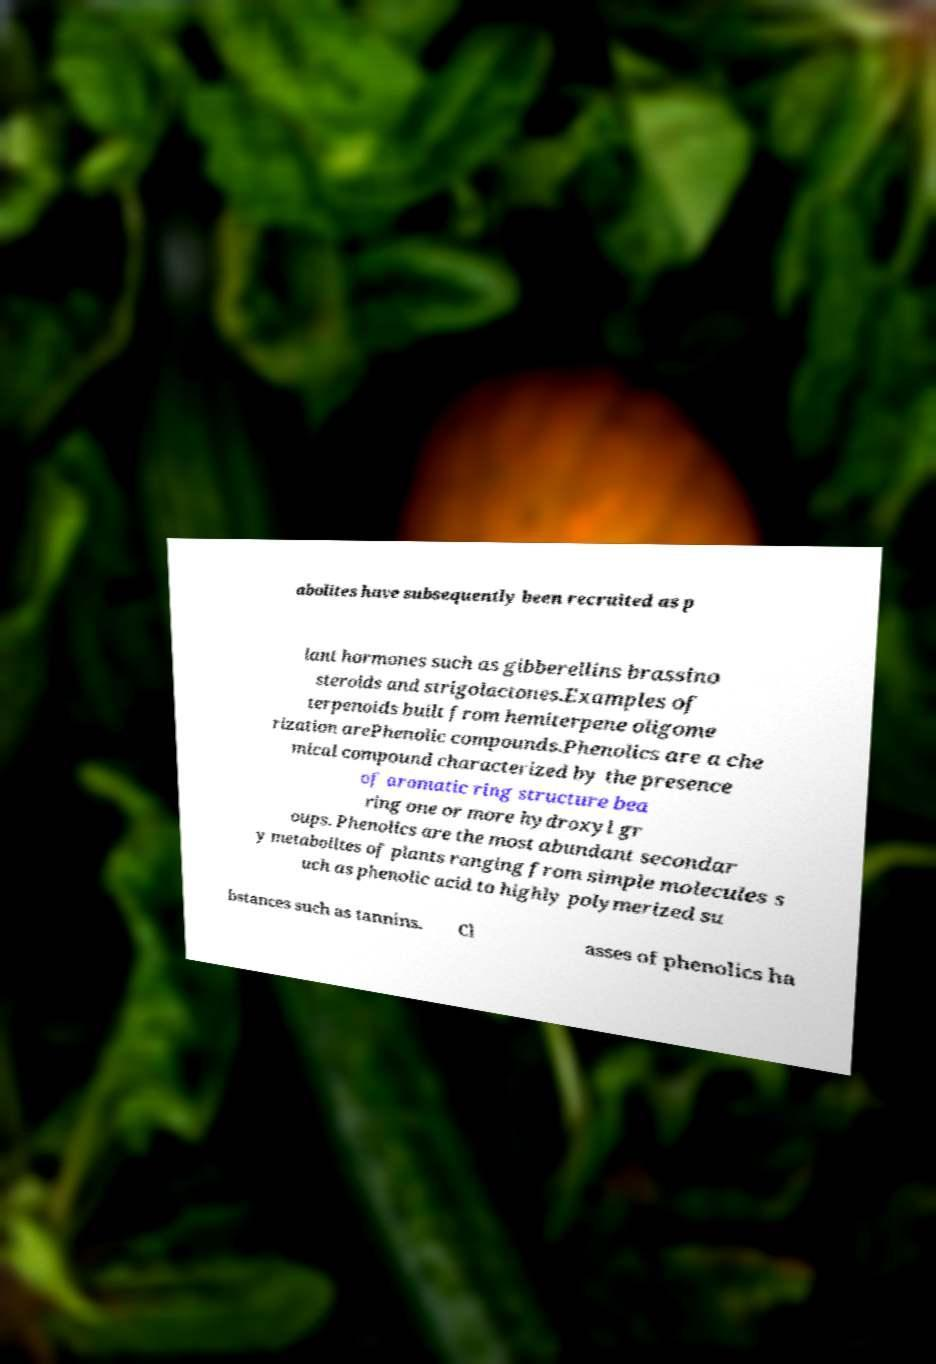There's text embedded in this image that I need extracted. Can you transcribe it verbatim? abolites have subsequently been recruited as p lant hormones such as gibberellins brassino steroids and strigolactones.Examples of terpenoids built from hemiterpene oligome rization arePhenolic compounds.Phenolics are a che mical compound characterized by the presence of aromatic ring structure bea ring one or more hydroxyl gr oups. Phenolics are the most abundant secondar y metabolites of plants ranging from simple molecules s uch as phenolic acid to highly polymerized su bstances such as tannins. Cl asses of phenolics ha 